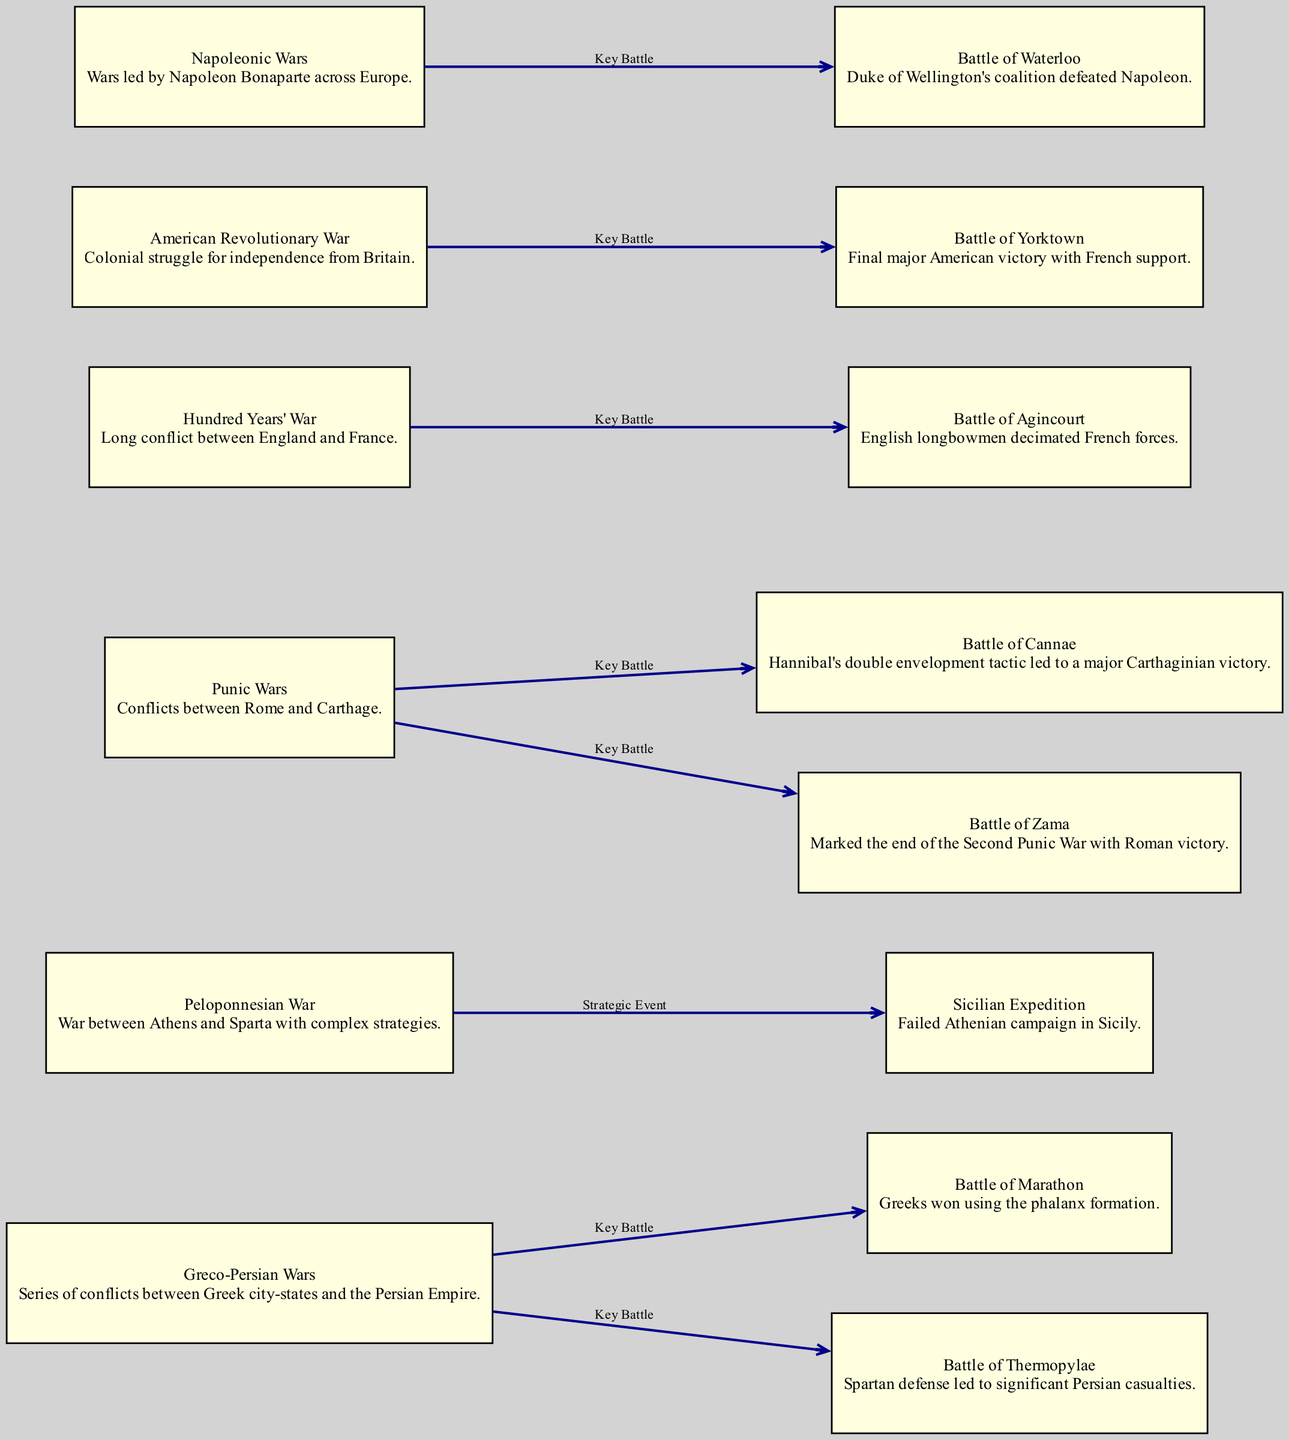What is the relationship between the Greco-Persian Wars and the Battle of Marathon? The diagram shows an edge from the Greco-Persian Wars node to the Battle of Marathon node, labeled "Key Battle." This indicates that the Battle of Marathon is a significant event associated with the Greco-Persian Wars.
Answer: Key Battle How many key battles are indicated in the Punic Wars? The diagram has two edges leading from the Punic Wars node to the Battle of Cannae and the Battle of Zama, indicating that these are both key battles related to the Punic Wars. Therefore, the count of key battles is two.
Answer: 2 What major war is the Battle of Yorktown associated with? There is a directed edge from the American Revolutionary War node to the Battle of Yorktown node, which shows that Battle of Yorktown is a key battle within the American Revolutionary War.
Answer: American Revolutionary War Which battle involved the use of longbowmen? The diagram has an edge from the Hundred Years' War to the Battle of Agincourt, indicating that the Battle of Agincourt is related to the Hundred Years' War and specifically involved English longbowmen decimating French forces.
Answer: Battle of Agincourt What is the total number of nodes in the diagram? The diagram includes a list of nodes, including those for various wars and battles. By counting, we find there are 15 nodes in total.
Answer: 15 Which two battles are linked to the Peloponnesian War as strategic events? The diagram has an edge from the Peloponnesian War node to the Sicilian Expedition node, indicating that the Sicilian Expedition is a strategic event related to the Peloponnesian War. However, there is only one such strategic event indicated, so the answer will be just that expedition.
Answer: Sicilian Expedition Who led the coalition that defeated Napoleon at Waterloo? The Battle of Waterloo node mentions the "Duke of Wellington's coalition" which indicates that he was the leader responsible for the defeat of Napoleon.
Answer: Duke of Wellington Identify a historical conflict characterized by complex strategies between two city-states. The Peloponnesian War node specifically mentions the conflict being between Athens and Sparta and the complexity of the strategies involved.
Answer: Peloponnesian War 